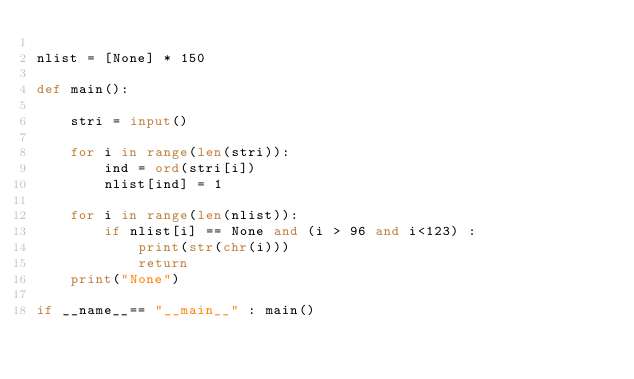<code> <loc_0><loc_0><loc_500><loc_500><_Python_>
nlist = [None] * 150

def main():
    
    stri = input()
    
    for i in range(len(stri)):
        ind = ord(stri[i])
        nlist[ind] = 1
    
    for i in range(len(nlist)):
        if nlist[i] == None and (i > 96 and i<123) :
            print(str(chr(i)))
            return
    print("None")

if __name__== "__main__" : main()</code> 